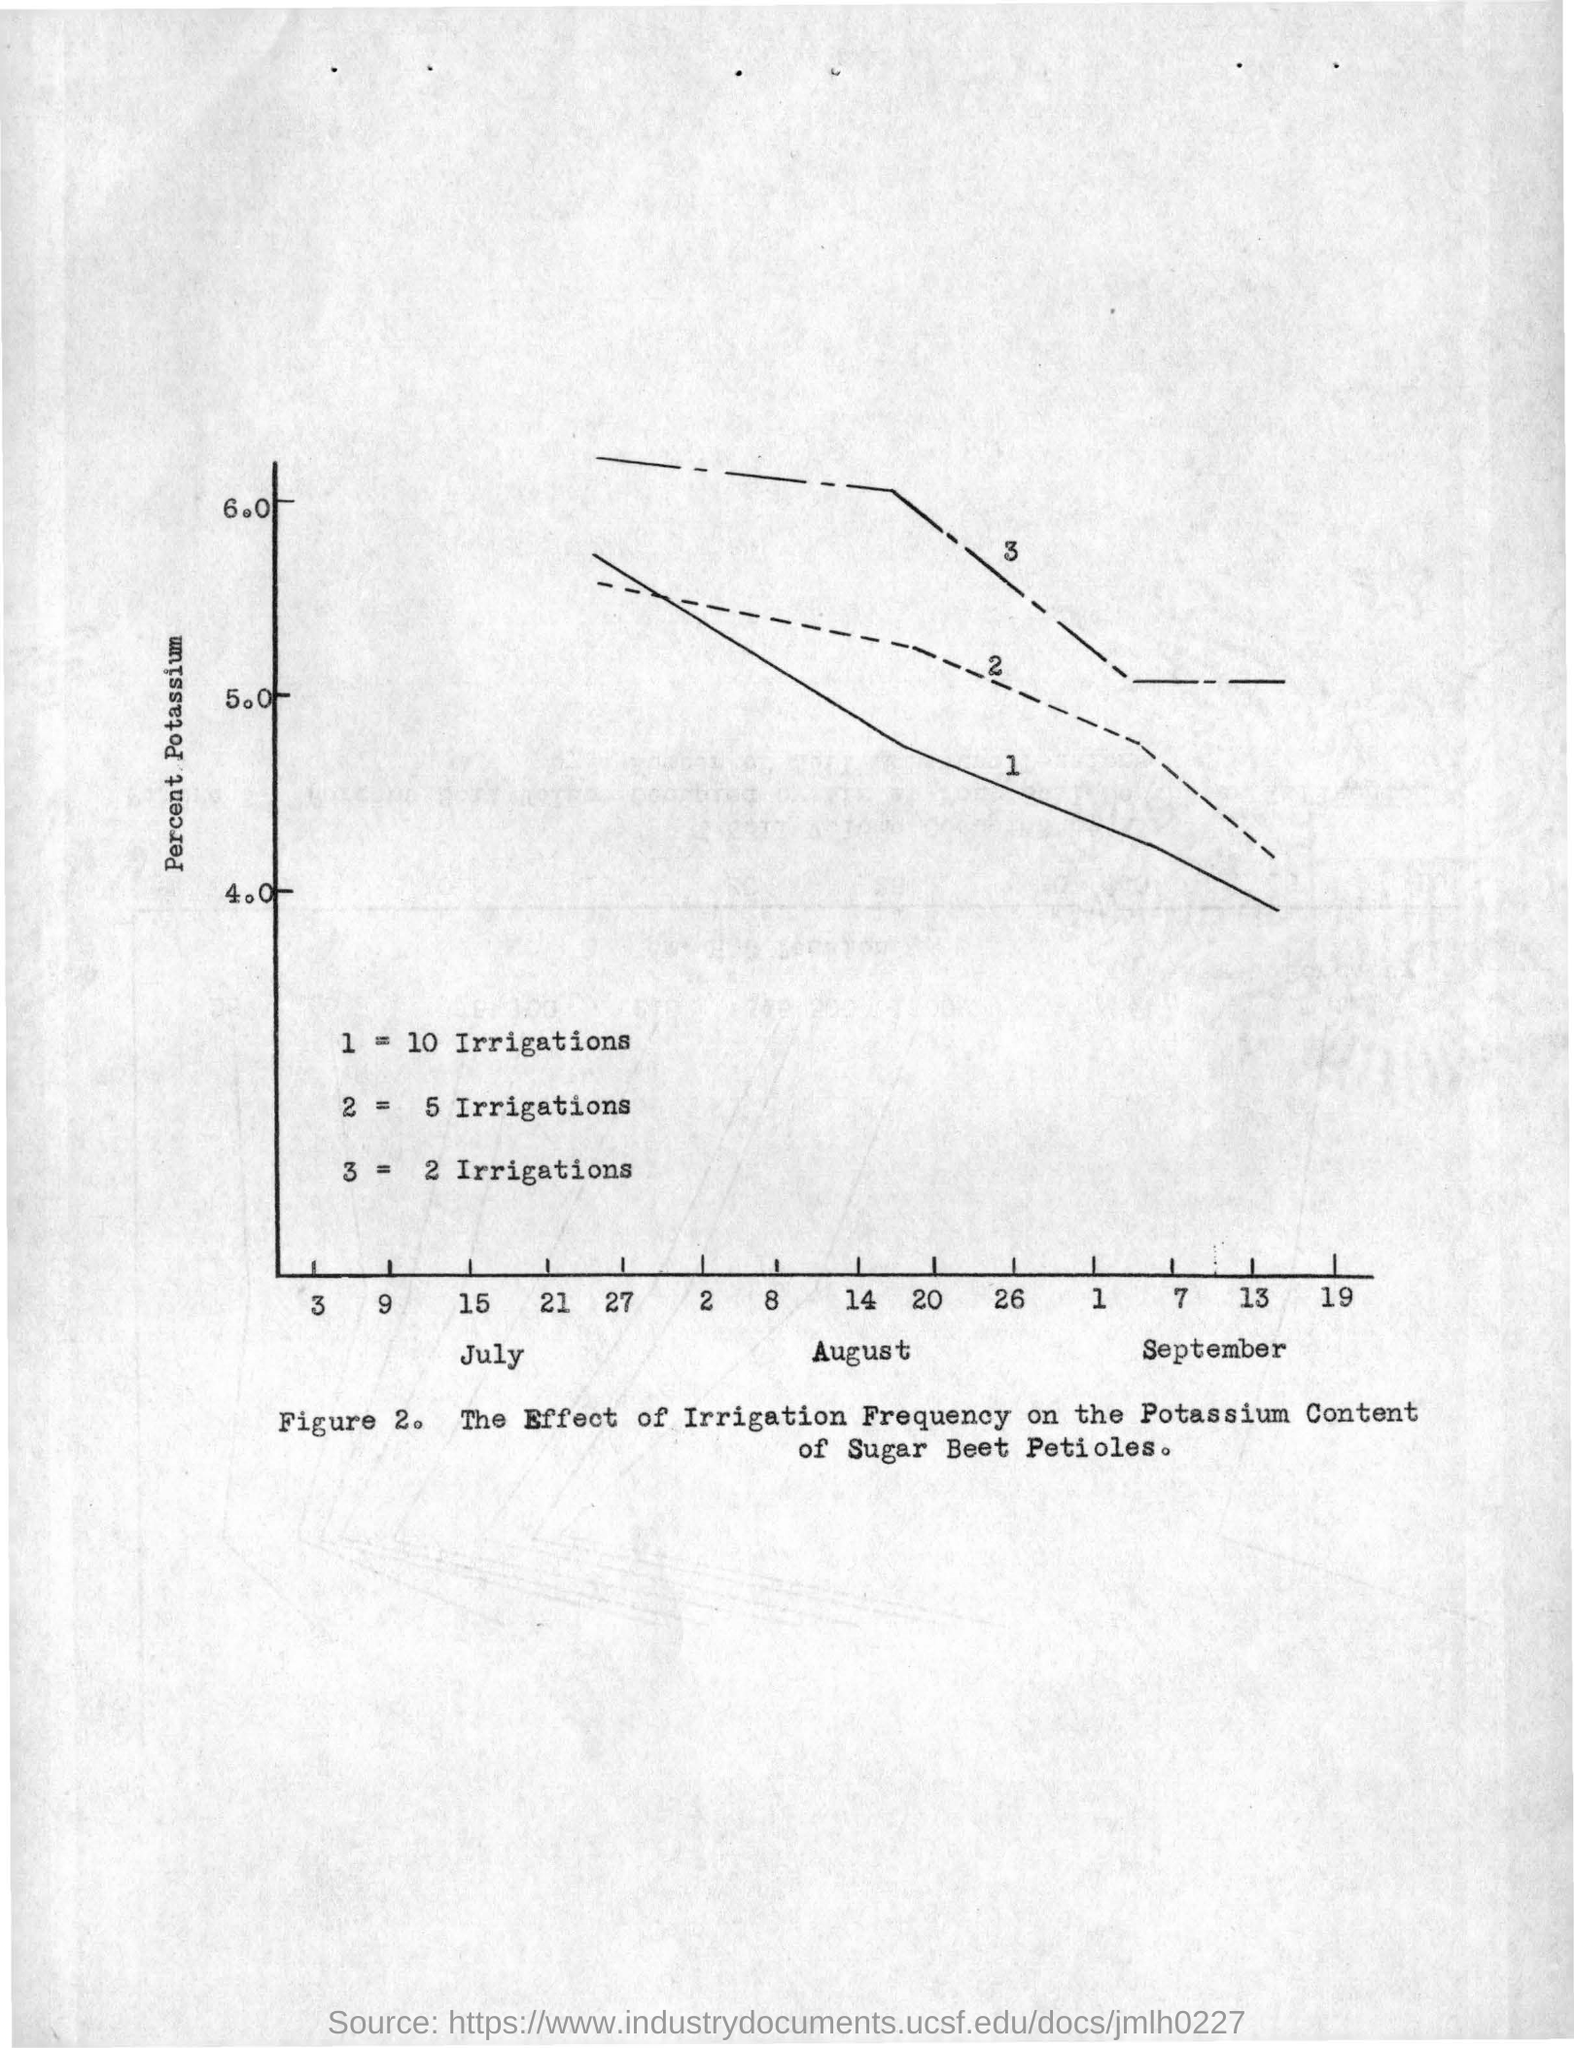What is plotted in the y-axis?
Keep it short and to the point. Percent Potassium. 